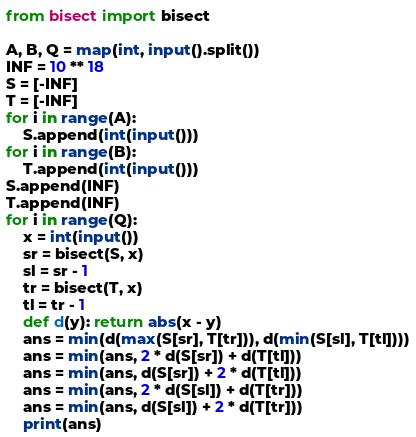Convert code to text. <code><loc_0><loc_0><loc_500><loc_500><_Python_>from bisect import bisect

A, B, Q = map(int, input().split())
INF = 10 ** 18
S = [-INF]
T = [-INF]
for i in range(A):
    S.append(int(input()))
for i in range(B):
    T.append(int(input()))
S.append(INF)
T.append(INF)
for i in range(Q):
    x = int(input())
    sr = bisect(S, x)
    sl = sr - 1
    tr = bisect(T, x)
    tl = tr - 1
    def d(y): return abs(x - y)
    ans = min(d(max(S[sr], T[tr])), d(min(S[sl], T[tl])))
    ans = min(ans, 2 * d(S[sr]) + d(T[tl]))
    ans = min(ans, d(S[sr]) + 2 * d(T[tl]))
    ans = min(ans, 2 * d(S[sl]) + d(T[tr]))
    ans = min(ans, d(S[sl]) + 2 * d(T[tr]))
    print(ans)
</code> 